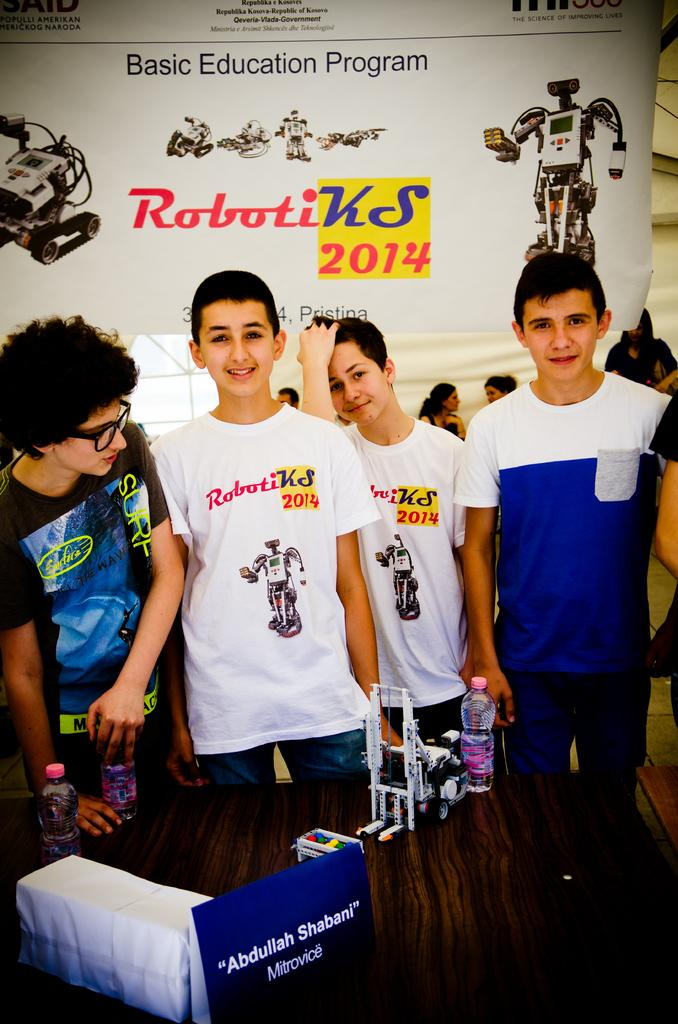<image>
Render a clear and concise summary of the photo. The year 2014 can be seen on a wall behind some kids. 